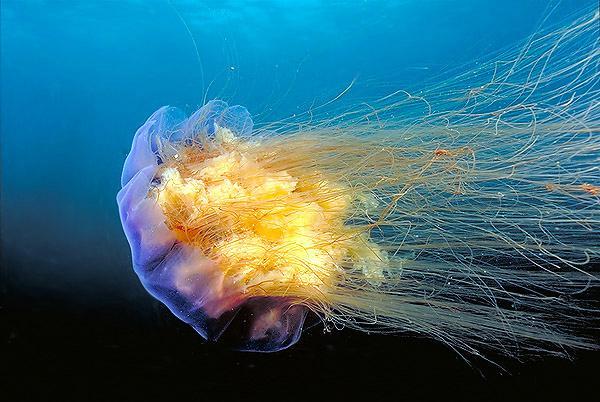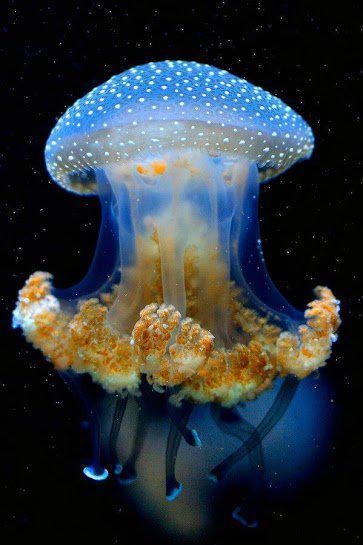The first image is the image on the left, the second image is the image on the right. For the images displayed, is the sentence "At least one of the jellyfish clearly has white spots all over the bell." factually correct? Answer yes or no. Yes. The first image is the image on the left, the second image is the image on the right. Evaluate the accuracy of this statement regarding the images: "in the left image a jellyfish is swimming toward the left". Is it true? Answer yes or no. Yes. 